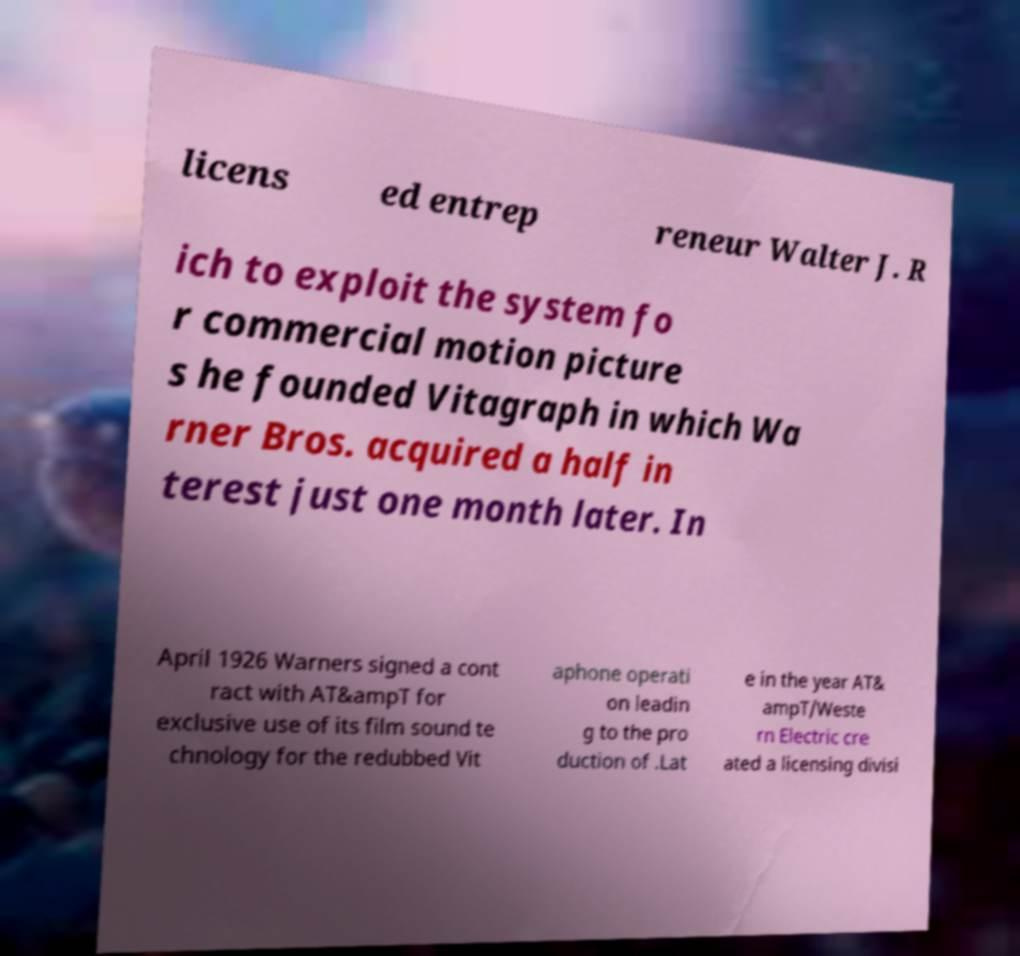There's text embedded in this image that I need extracted. Can you transcribe it verbatim? licens ed entrep reneur Walter J. R ich to exploit the system fo r commercial motion picture s he founded Vitagraph in which Wa rner Bros. acquired a half in terest just one month later. In April 1926 Warners signed a cont ract with AT&ampT for exclusive use of its film sound te chnology for the redubbed Vit aphone operati on leadin g to the pro duction of .Lat e in the year AT& ampT/Weste rn Electric cre ated a licensing divisi 